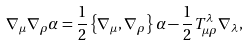Convert formula to latex. <formula><loc_0><loc_0><loc_500><loc_500>\nabla _ { \mu } \nabla _ { \rho } \alpha = \frac { 1 } { 2 } \left \{ \nabla _ { \mu } , \nabla _ { \rho } \right \} \alpha - \frac { 1 } { 2 } T ^ { \lambda } _ { \mu \rho } \nabla _ { \lambda } ,</formula> 